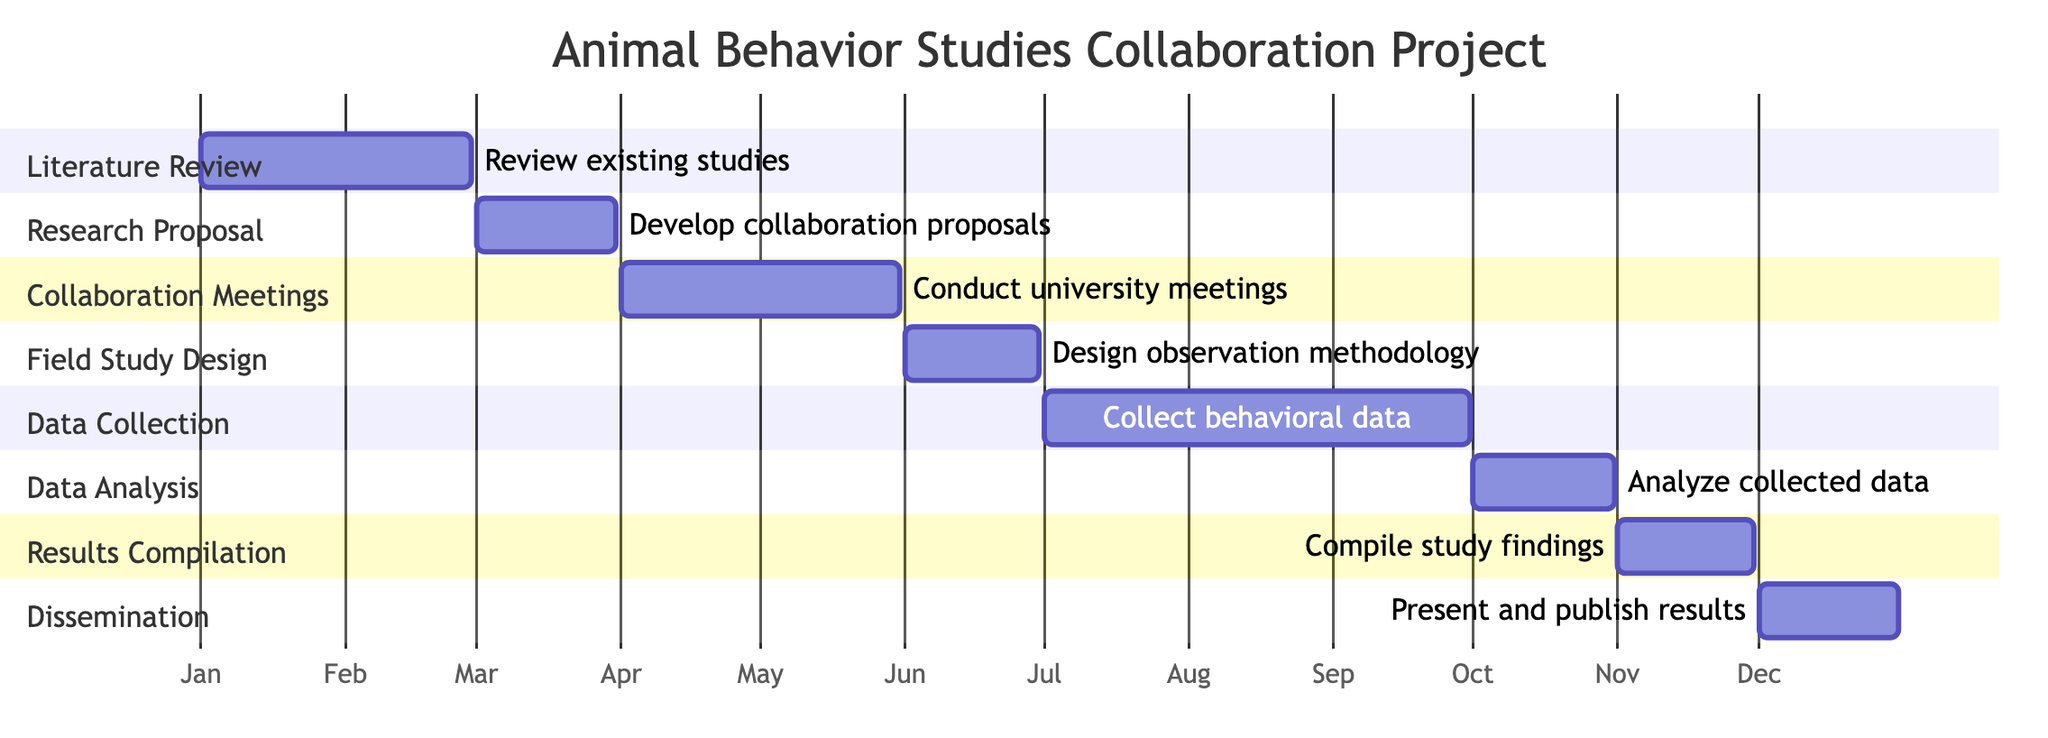What is the duration of the Data Collection phase? The Data Collection phase is indicated in the diagram. It lasts from July to September, covering the specified months.
Answer: July - September How many phases are there in the project? Counting the sections in the Gantt chart, there are eight distinct phases listed.
Answer: 8 What is the first phase of the project? The diagram starts with the Literature Review phase, as it is the first section shown.
Answer: Literature Review Which phase occurs in October? The Gantt chart specifies that Data Analysis takes place in October.
Answer: Data Analysis What is the last phase of the project? Looking at the timeline, the last phase in the Gantt chart is Dissemination of Findings, which occurs in December.
Answer: Dissemination of Findings During which months are the University Collaboration Meetings scheduled? By examining the diagram, University Collaboration Meetings are scheduled from April through May, as shown in the section details.
Answer: April - May How long does the Research Proposal Development phase last? The diagram indicates that the Research Proposal Development phase lasts for the entire month of March.
Answer: March Which phase immediately follows the Field Study Design? The diagram shows that Data Collection follows Field Study Design, as the timeline progresses directly from June to July.
Answer: Data Collection What activities are included in the Dissemination of Findings phase? By reviewing the section for Dissemination, this phase includes presenting results at conferences and publishing in journals.
Answer: Presenting and publishing results 